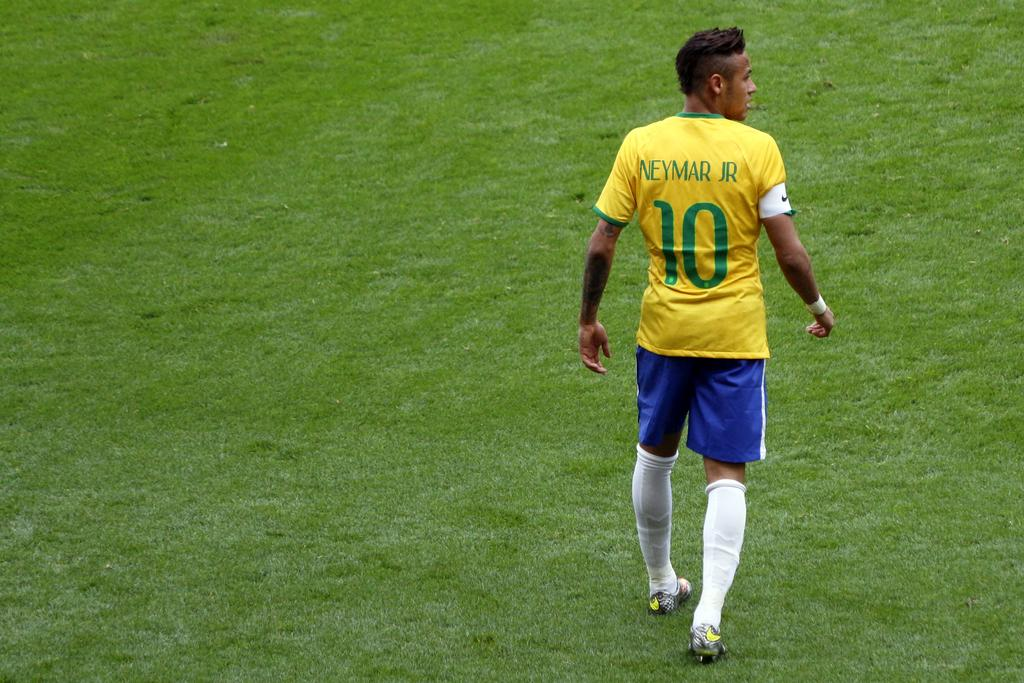<image>
Give a short and clear explanation of the subsequent image. A man wearing a soccer jersey depicting the name Neymar Jr 